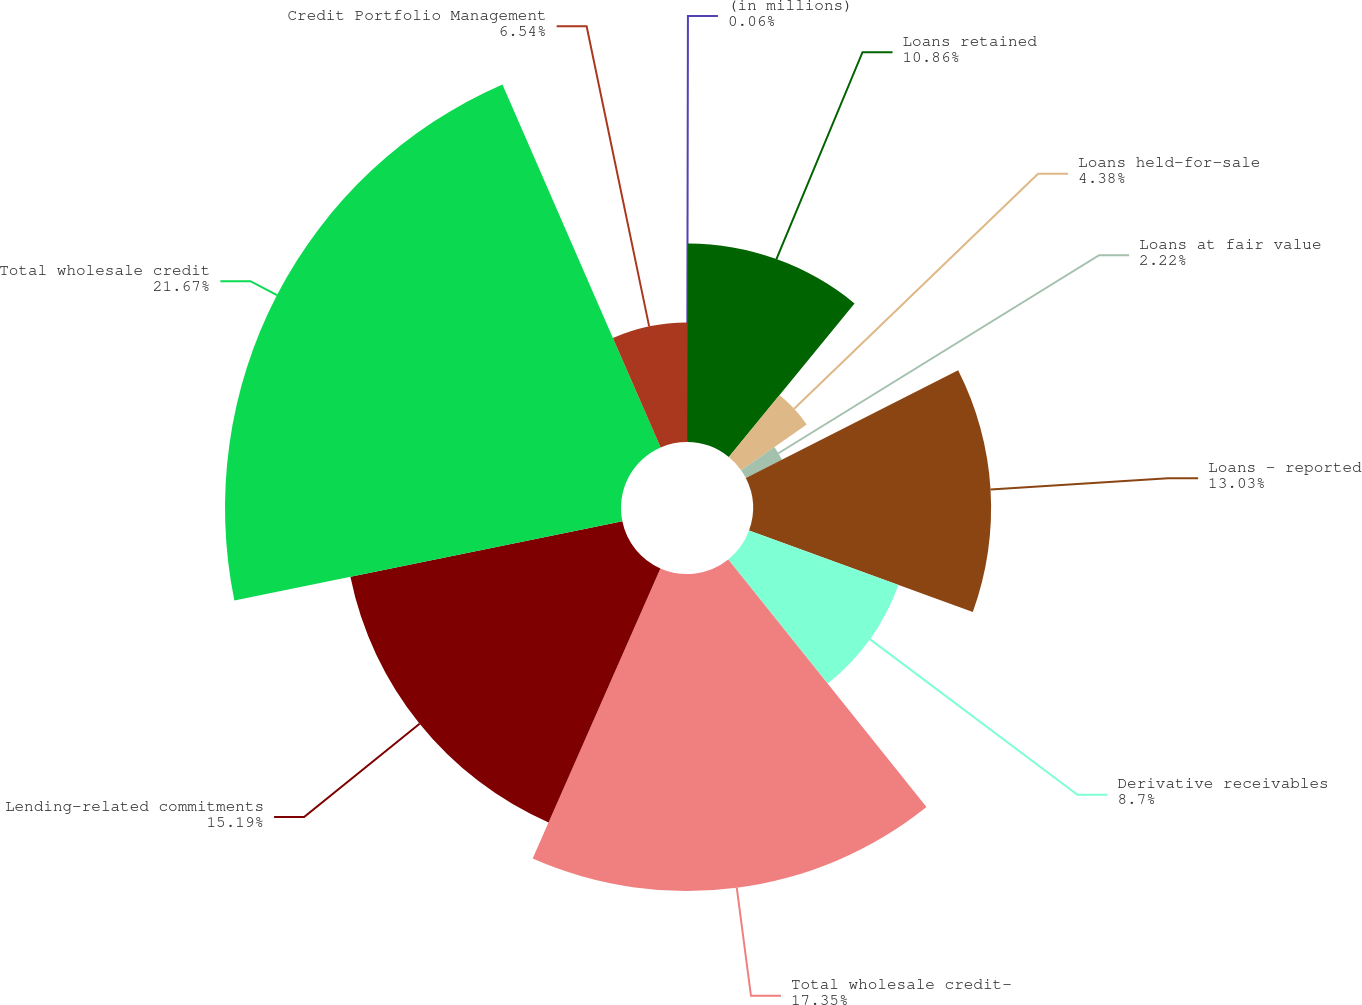<chart> <loc_0><loc_0><loc_500><loc_500><pie_chart><fcel>(in millions)<fcel>Loans retained<fcel>Loans held-for-sale<fcel>Loans at fair value<fcel>Loans - reported<fcel>Derivative receivables<fcel>Total wholesale credit-<fcel>Lending-related commitments<fcel>Total wholesale credit<fcel>Credit Portfolio Management<nl><fcel>0.06%<fcel>10.86%<fcel>4.38%<fcel>2.22%<fcel>13.03%<fcel>8.7%<fcel>17.35%<fcel>15.19%<fcel>21.67%<fcel>6.54%<nl></chart> 